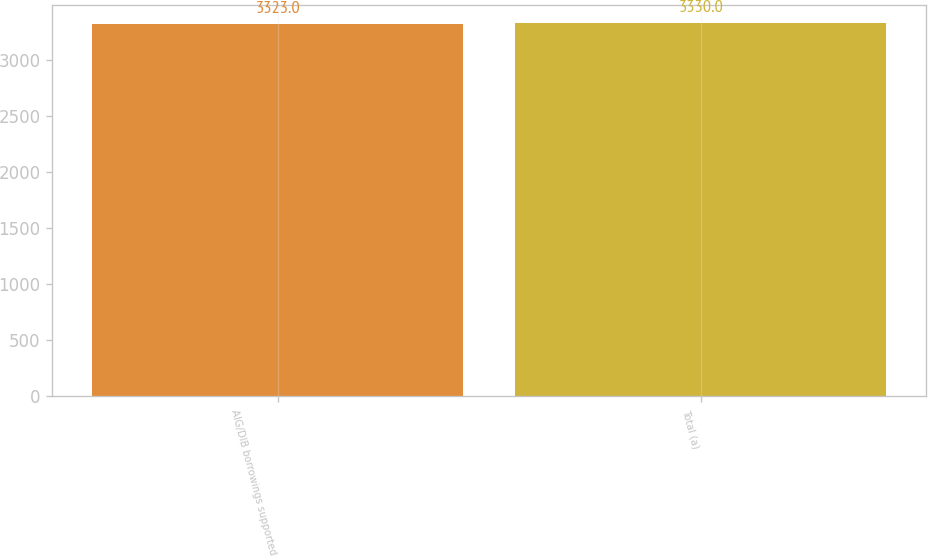<chart> <loc_0><loc_0><loc_500><loc_500><bar_chart><fcel>AIG/DIB borrowings supported<fcel>Total (a)<nl><fcel>3323<fcel>3330<nl></chart> 